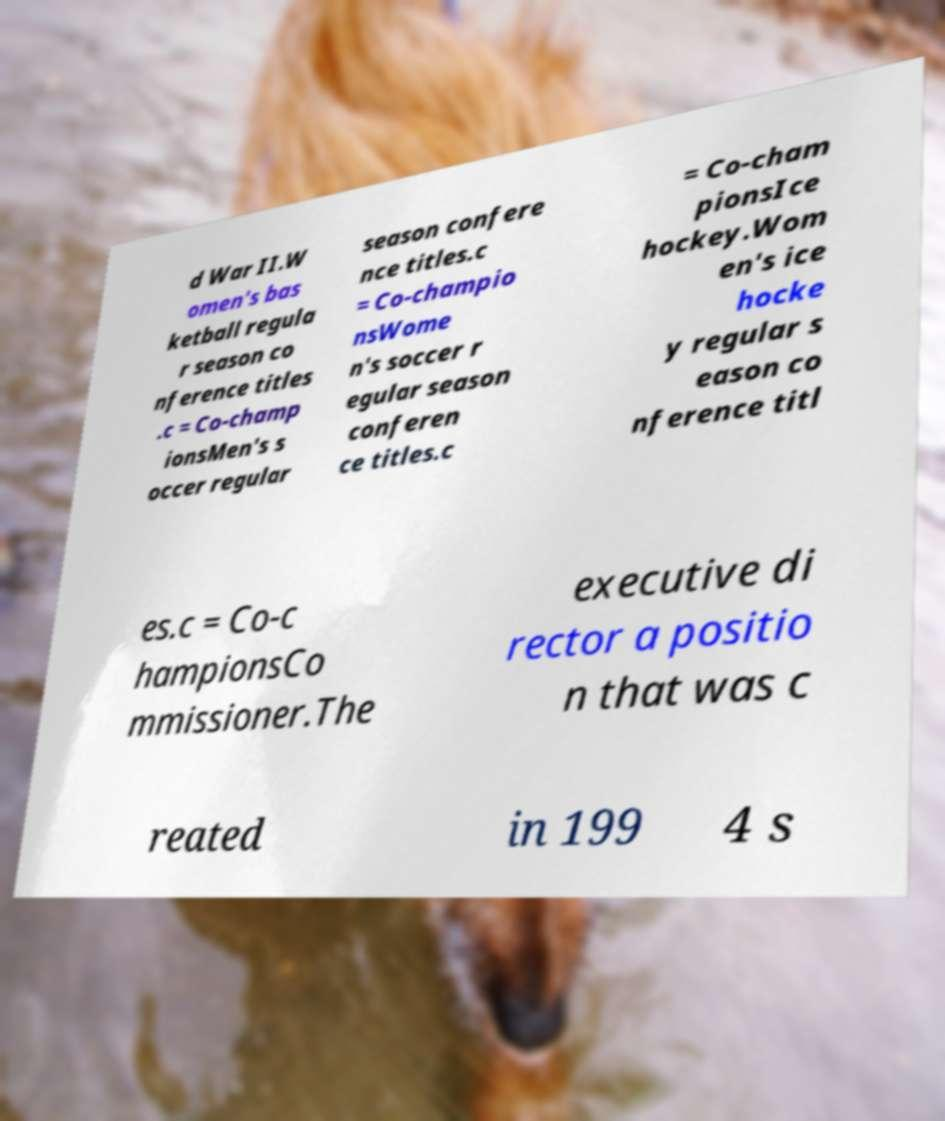Can you read and provide the text displayed in the image?This photo seems to have some interesting text. Can you extract and type it out for me? d War II.W omen's bas ketball regula r season co nference titles .c = Co-champ ionsMen's s occer regular season confere nce titles.c = Co-champio nsWome n's soccer r egular season conferen ce titles.c = Co-cham pionsIce hockey.Wom en's ice hocke y regular s eason co nference titl es.c = Co-c hampionsCo mmissioner.The executive di rector a positio n that was c reated in 199 4 s 